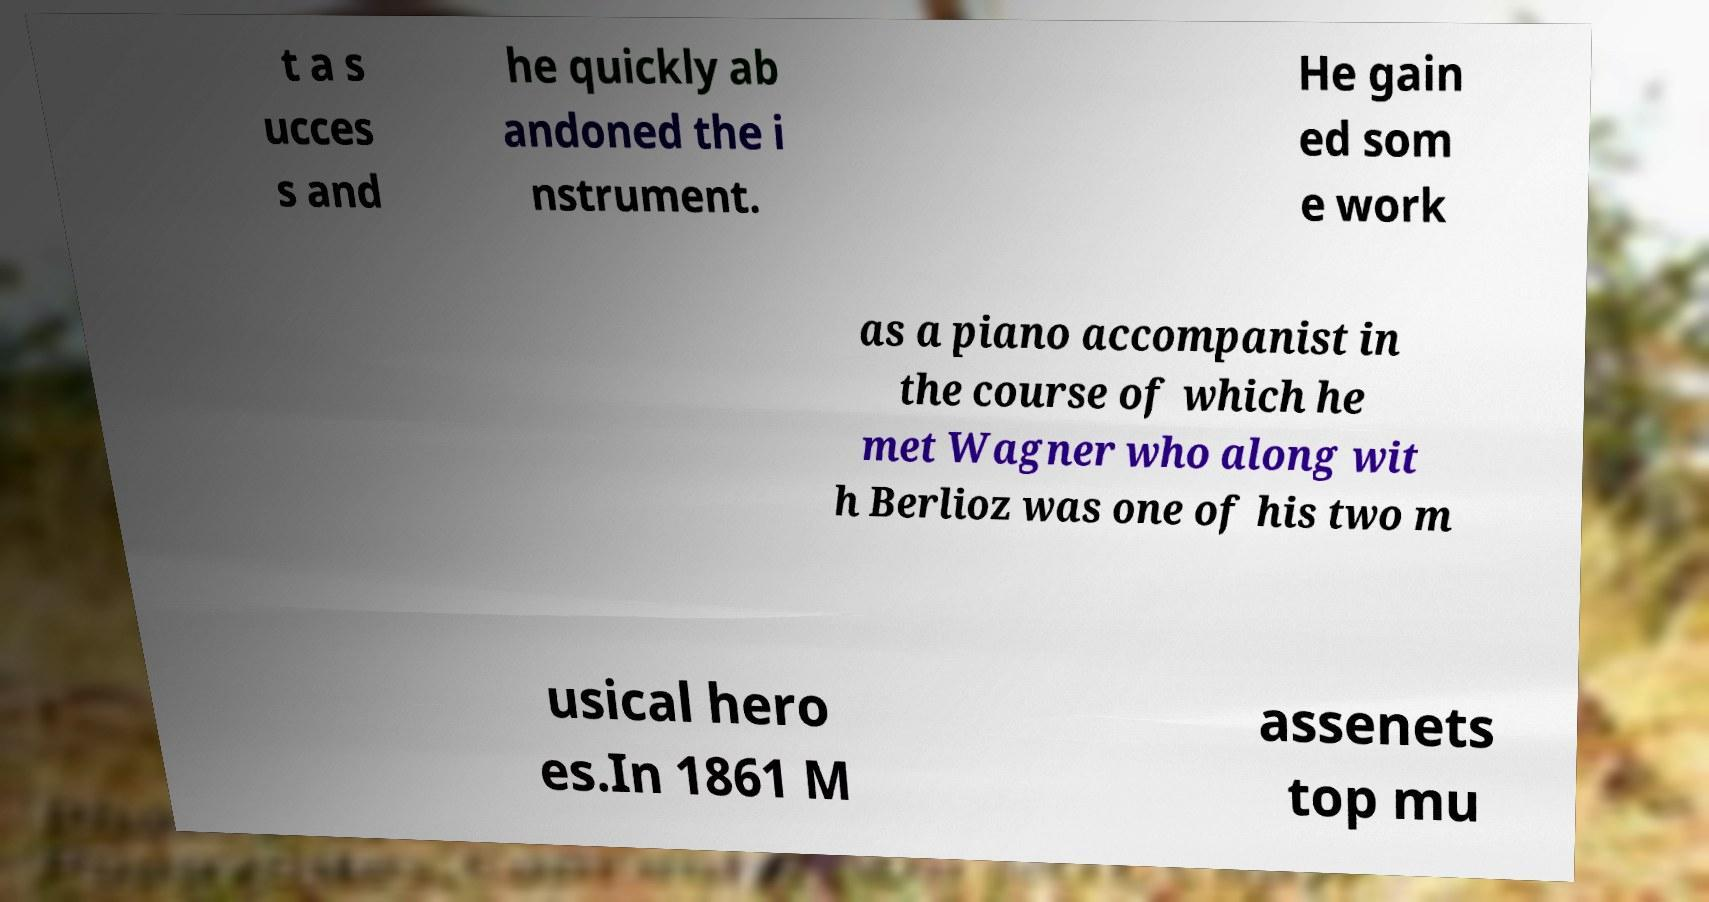I need the written content from this picture converted into text. Can you do that? t a s ucces s and he quickly ab andoned the i nstrument. He gain ed som e work as a piano accompanist in the course of which he met Wagner who along wit h Berlioz was one of his two m usical hero es.In 1861 M assenets top mu 